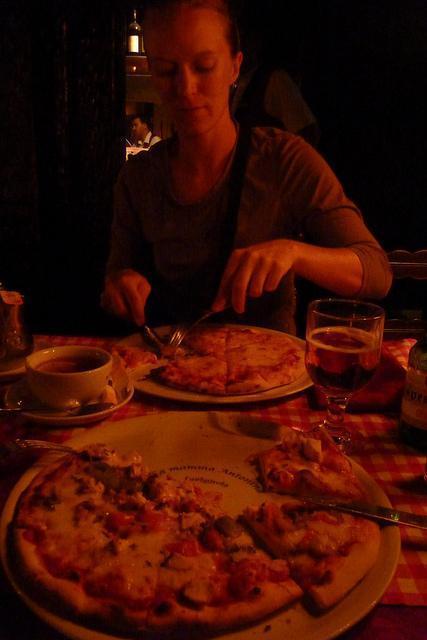How many people are at the table?
Give a very brief answer. 1. How many pizzas can you see?
Give a very brief answer. 4. 